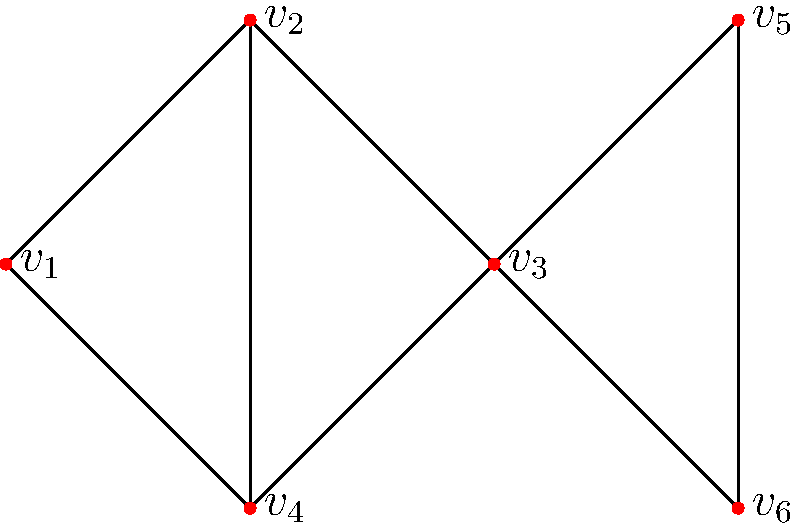Given the undirected graph shown above, calculate the degree centrality and betweenness centrality for vertex $v_3$. Round your answers to three decimal places. To calculate the degree centrality and betweenness centrality for vertex $v_3$, we'll follow these steps:

1. Degree Centrality:
   - Count the number of edges connected to $v_3$: 3 edges
   - Total number of vertices: 6
   - Degree Centrality = $\frac{\text{number of connections}}{\text{total possible connections}} = \frac{3}{5} = 0.600$

2. Betweenness Centrality:
   - Identify all shortest paths between pairs of vertices
   - Count how many of these paths pass through $v_3$
   - Calculate the betweenness centrality using the formula:
     $$ BC(v) = \sum_{s \neq v \neq t} \frac{\sigma_{st}(v)}{\sigma_{st}} $$
     where $\sigma_{st}$ is the total number of shortest paths from node $s$ to node $t$,
     and $\sigma_{st}(v)$ is the number of those paths passing through $v$

   Shortest paths through $v_3$:
   - $v_1 - v_3 - v_5$: 1 out of 1
   - $v_1 - v_3 - v_6$: 1 out of 1
   - $v_2 - v_3 - v_5$: 1 out of 1
   - $v_2 - v_3 - v_6$: 1 out of 1
   - $v_4 - v_3 - v_5$: 1 out of 1
   - $v_4 - v_3 - v_6$: 1 out of 1

   Sum of fractions: 6

   Normalize by dividing by $(n-1)(n-2)/2$, where $n$ is the number of vertices:
   $$ BC(v_3) = \frac{6}{(6-1)(6-2)/2} = \frac{6}{10} = 0.600 $$

Therefore, the degree centrality for $v_3$ is 0.600, and the betweenness centrality for $v_3$ is also 0.600.
Answer: Degree centrality: 0.600, Betweenness centrality: 0.600 